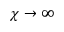Convert formula to latex. <formula><loc_0><loc_0><loc_500><loc_500>\chi \to \infty</formula> 